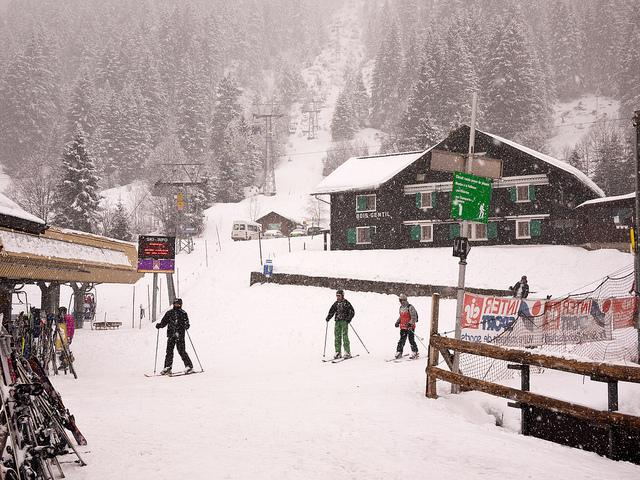What kind of stand is shown?

Choices:
A) rental
B) lunch
C) produce
D) drink rental 